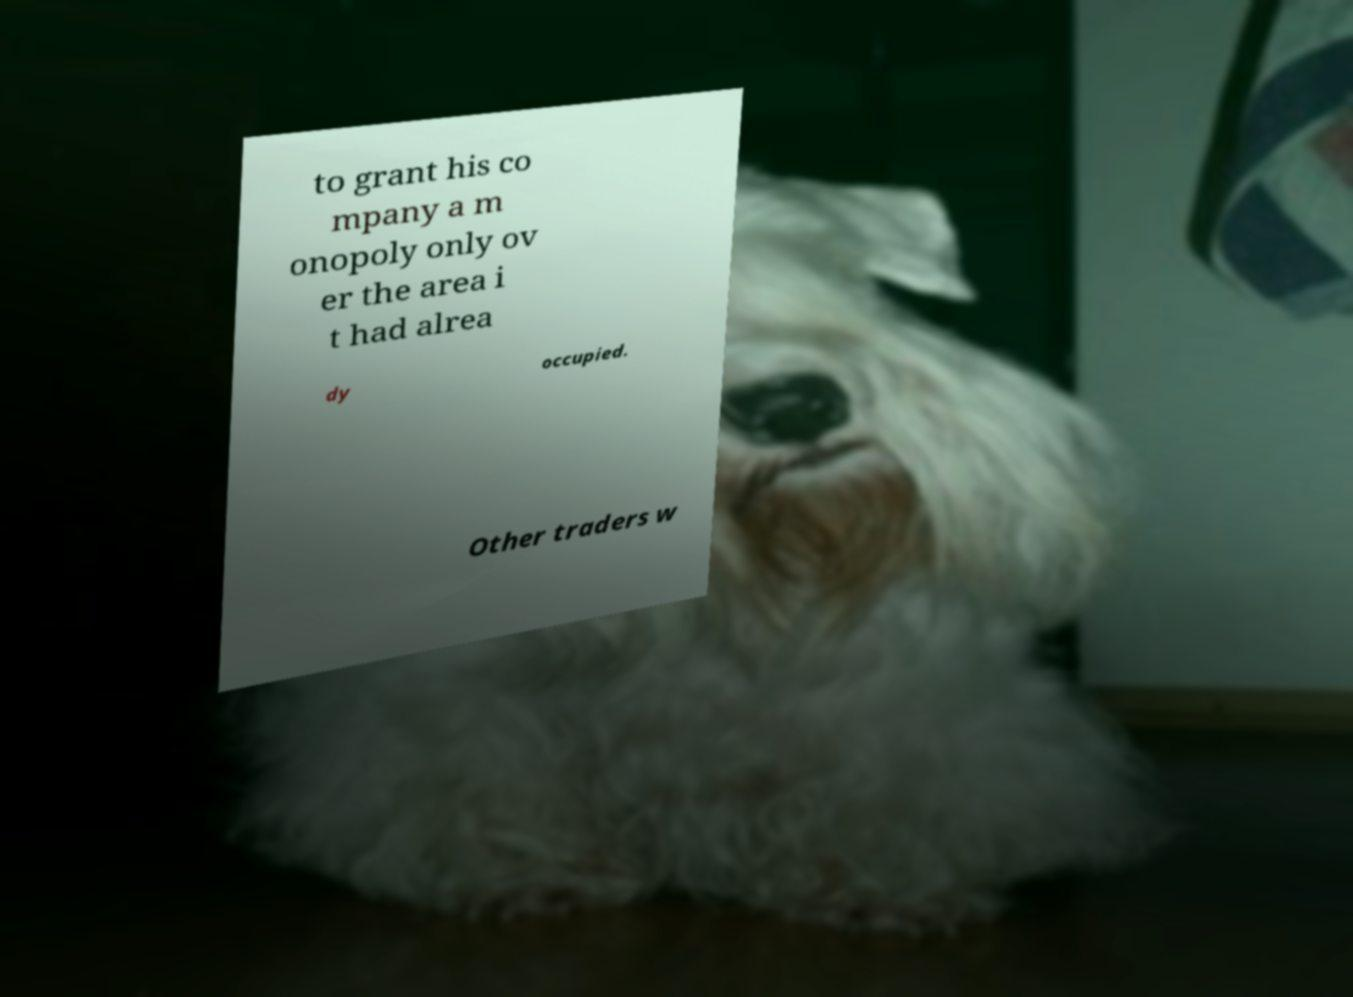Can you read and provide the text displayed in the image?This photo seems to have some interesting text. Can you extract and type it out for me? to grant his co mpany a m onopoly only ov er the area i t had alrea dy occupied. Other traders w 